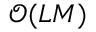Convert formula to latex. <formula><loc_0><loc_0><loc_500><loc_500>\mathcal { O } ( L M )</formula> 